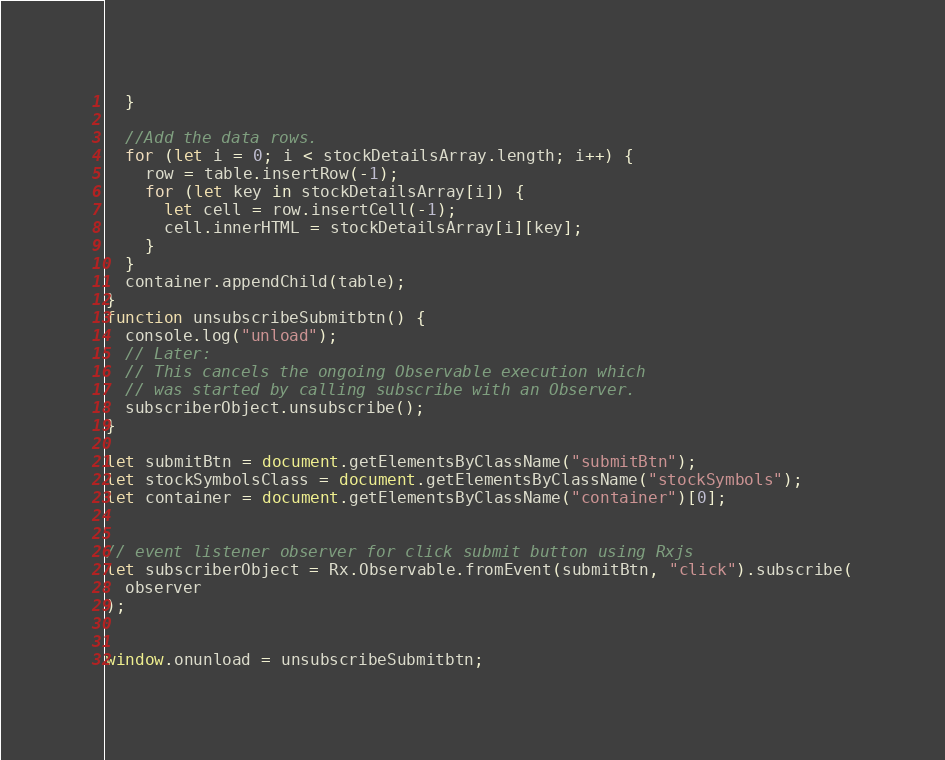Convert code to text. <code><loc_0><loc_0><loc_500><loc_500><_JavaScript_>  }

  //Add the data rows.
  for (let i = 0; i < stockDetailsArray.length; i++) {
    row = table.insertRow(-1);
    for (let key in stockDetailsArray[i]) {
      let cell = row.insertCell(-1);
      cell.innerHTML = stockDetailsArray[i][key];
    }
  }
  container.appendChild(table);
}
function unsubscribeSubmitbtn() {
  console.log("unload");
  // Later:
  // This cancels the ongoing Observable execution which
  // was started by calling subscribe with an Observer.
  subscriberObject.unsubscribe();
}

let submitBtn = document.getElementsByClassName("submitBtn");
let stockSymbolsClass = document.getElementsByClassName("stockSymbols");
let container = document.getElementsByClassName("container")[0];


// event listener observer for click submit button using Rxjs
let subscriberObject = Rx.Observable.fromEvent(submitBtn, "click").subscribe(
  observer
);


window.onunload = unsubscribeSubmitbtn;
</code> 